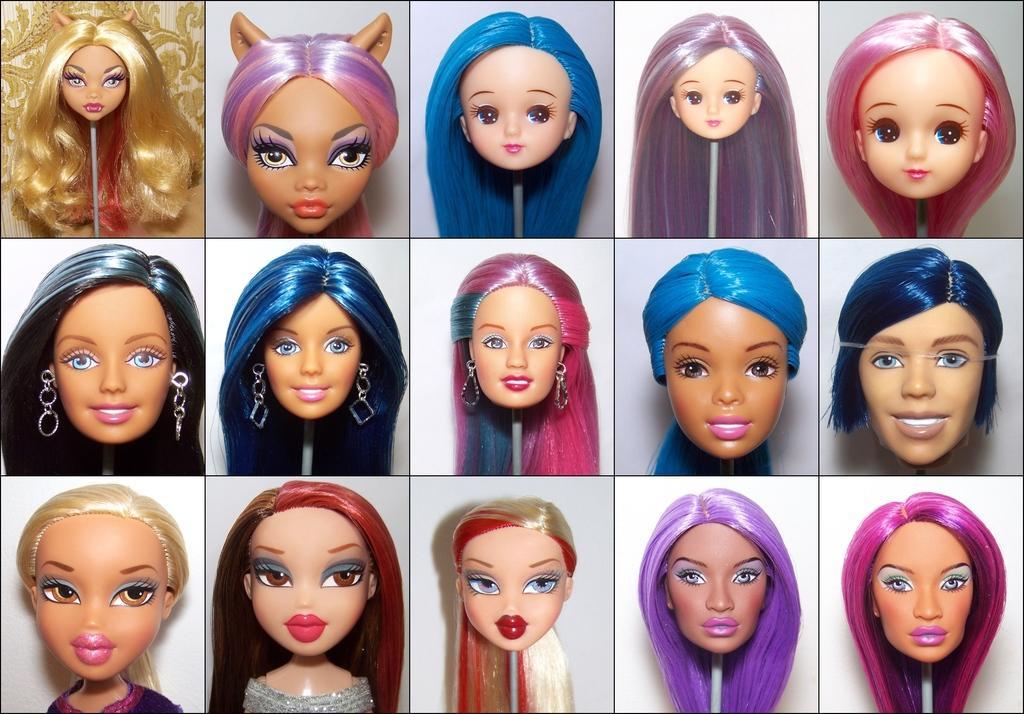In one or two sentences, can you explain what this image depicts? A collage picture of a doll faces. 